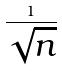Convert formula to latex. <formula><loc_0><loc_0><loc_500><loc_500>\frac { 1 } { \sqrt { n } }</formula> 